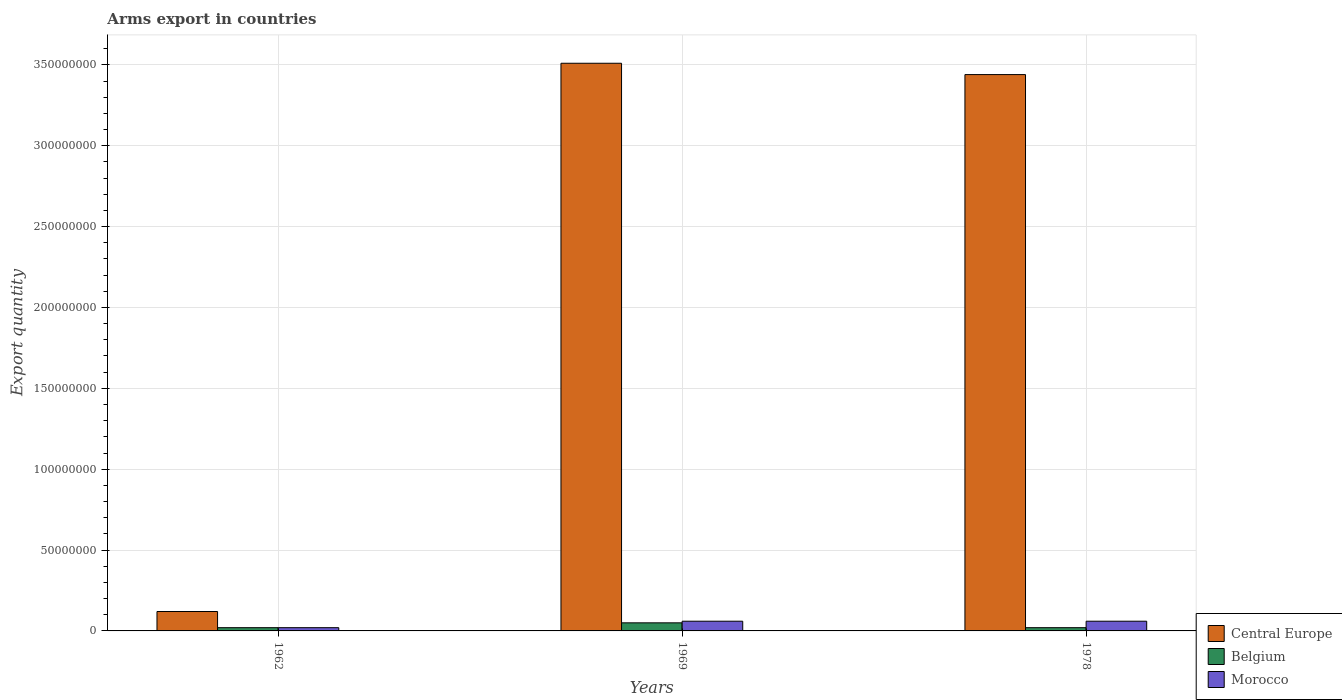How many different coloured bars are there?
Keep it short and to the point. 3. Are the number of bars per tick equal to the number of legend labels?
Offer a very short reply. Yes. Are the number of bars on each tick of the X-axis equal?
Keep it short and to the point. Yes. How many bars are there on the 2nd tick from the left?
Your answer should be very brief. 3. What is the label of the 3rd group of bars from the left?
Offer a very short reply. 1978. Across all years, what is the maximum total arms export in Belgium?
Provide a succinct answer. 5.00e+06. In which year was the total arms export in Belgium maximum?
Give a very brief answer. 1969. In which year was the total arms export in Belgium minimum?
Make the answer very short. 1962. What is the total total arms export in Morocco in the graph?
Ensure brevity in your answer.  1.40e+07. What is the difference between the total arms export in Morocco in 1962 and the total arms export in Central Europe in 1978?
Give a very brief answer. -3.42e+08. What is the average total arms export in Central Europe per year?
Your response must be concise. 2.36e+08. In the year 1969, what is the difference between the total arms export in Central Europe and total arms export in Belgium?
Ensure brevity in your answer.  3.46e+08. In how many years, is the total arms export in Central Europe greater than 280000000?
Provide a short and direct response. 2. What is the ratio of the total arms export in Central Europe in 1962 to that in 1978?
Your response must be concise. 0.03. What is the difference between the highest and the lowest total arms export in Central Europe?
Give a very brief answer. 3.39e+08. In how many years, is the total arms export in Central Europe greater than the average total arms export in Central Europe taken over all years?
Keep it short and to the point. 2. What does the 1st bar from the left in 1978 represents?
Provide a short and direct response. Central Europe. What does the 1st bar from the right in 1962 represents?
Offer a very short reply. Morocco. Is it the case that in every year, the sum of the total arms export in Central Europe and total arms export in Morocco is greater than the total arms export in Belgium?
Provide a succinct answer. Yes. Are all the bars in the graph horizontal?
Offer a terse response. No. How many years are there in the graph?
Your response must be concise. 3. What is the difference between two consecutive major ticks on the Y-axis?
Make the answer very short. 5.00e+07. Are the values on the major ticks of Y-axis written in scientific E-notation?
Give a very brief answer. No. How many legend labels are there?
Keep it short and to the point. 3. How are the legend labels stacked?
Offer a very short reply. Vertical. What is the title of the graph?
Give a very brief answer. Arms export in countries. What is the label or title of the X-axis?
Your answer should be very brief. Years. What is the label or title of the Y-axis?
Make the answer very short. Export quantity. What is the Export quantity of Morocco in 1962?
Your answer should be compact. 2.00e+06. What is the Export quantity of Central Europe in 1969?
Your answer should be compact. 3.51e+08. What is the Export quantity of Morocco in 1969?
Offer a very short reply. 6.00e+06. What is the Export quantity in Central Europe in 1978?
Your answer should be very brief. 3.44e+08. What is the Export quantity of Morocco in 1978?
Your response must be concise. 6.00e+06. Across all years, what is the maximum Export quantity of Central Europe?
Offer a terse response. 3.51e+08. Across all years, what is the maximum Export quantity in Morocco?
Offer a very short reply. 6.00e+06. Across all years, what is the minimum Export quantity in Belgium?
Offer a very short reply. 2.00e+06. Across all years, what is the minimum Export quantity of Morocco?
Offer a very short reply. 2.00e+06. What is the total Export quantity of Central Europe in the graph?
Offer a very short reply. 7.07e+08. What is the total Export quantity of Belgium in the graph?
Offer a very short reply. 9.00e+06. What is the total Export quantity of Morocco in the graph?
Your answer should be very brief. 1.40e+07. What is the difference between the Export quantity of Central Europe in 1962 and that in 1969?
Offer a very short reply. -3.39e+08. What is the difference between the Export quantity in Belgium in 1962 and that in 1969?
Give a very brief answer. -3.00e+06. What is the difference between the Export quantity in Central Europe in 1962 and that in 1978?
Your answer should be compact. -3.32e+08. What is the difference between the Export quantity of Belgium in 1962 and that in 1978?
Your response must be concise. 0. What is the difference between the Export quantity of Morocco in 1962 and that in 1978?
Keep it short and to the point. -4.00e+06. What is the difference between the Export quantity of Central Europe in 1969 and that in 1978?
Give a very brief answer. 7.00e+06. What is the difference between the Export quantity in Belgium in 1969 and that in 1978?
Your response must be concise. 3.00e+06. What is the difference between the Export quantity of Central Europe in 1962 and the Export quantity of Belgium in 1969?
Ensure brevity in your answer.  7.00e+06. What is the difference between the Export quantity in Central Europe in 1962 and the Export quantity in Morocco in 1969?
Provide a succinct answer. 6.00e+06. What is the difference between the Export quantity of Belgium in 1962 and the Export quantity of Morocco in 1969?
Your answer should be very brief. -4.00e+06. What is the difference between the Export quantity of Belgium in 1962 and the Export quantity of Morocco in 1978?
Give a very brief answer. -4.00e+06. What is the difference between the Export quantity in Central Europe in 1969 and the Export quantity in Belgium in 1978?
Your answer should be very brief. 3.49e+08. What is the difference between the Export quantity of Central Europe in 1969 and the Export quantity of Morocco in 1978?
Make the answer very short. 3.45e+08. What is the difference between the Export quantity of Belgium in 1969 and the Export quantity of Morocco in 1978?
Provide a succinct answer. -1.00e+06. What is the average Export quantity of Central Europe per year?
Make the answer very short. 2.36e+08. What is the average Export quantity in Morocco per year?
Offer a very short reply. 4.67e+06. In the year 1962, what is the difference between the Export quantity in Belgium and Export quantity in Morocco?
Your answer should be very brief. 0. In the year 1969, what is the difference between the Export quantity of Central Europe and Export quantity of Belgium?
Your answer should be very brief. 3.46e+08. In the year 1969, what is the difference between the Export quantity of Central Europe and Export quantity of Morocco?
Keep it short and to the point. 3.45e+08. In the year 1969, what is the difference between the Export quantity of Belgium and Export quantity of Morocco?
Your answer should be compact. -1.00e+06. In the year 1978, what is the difference between the Export quantity in Central Europe and Export quantity in Belgium?
Your answer should be very brief. 3.42e+08. In the year 1978, what is the difference between the Export quantity in Central Europe and Export quantity in Morocco?
Provide a succinct answer. 3.38e+08. What is the ratio of the Export quantity of Central Europe in 1962 to that in 1969?
Keep it short and to the point. 0.03. What is the ratio of the Export quantity in Morocco in 1962 to that in 1969?
Offer a terse response. 0.33. What is the ratio of the Export quantity in Central Europe in 1962 to that in 1978?
Ensure brevity in your answer.  0.03. What is the ratio of the Export quantity in Belgium in 1962 to that in 1978?
Provide a short and direct response. 1. What is the ratio of the Export quantity in Morocco in 1962 to that in 1978?
Offer a terse response. 0.33. What is the ratio of the Export quantity of Central Europe in 1969 to that in 1978?
Keep it short and to the point. 1.02. What is the ratio of the Export quantity of Morocco in 1969 to that in 1978?
Offer a very short reply. 1. What is the difference between the highest and the second highest Export quantity in Belgium?
Provide a succinct answer. 3.00e+06. What is the difference between the highest and the lowest Export quantity of Central Europe?
Your response must be concise. 3.39e+08. What is the difference between the highest and the lowest Export quantity of Belgium?
Offer a very short reply. 3.00e+06. What is the difference between the highest and the lowest Export quantity in Morocco?
Provide a succinct answer. 4.00e+06. 